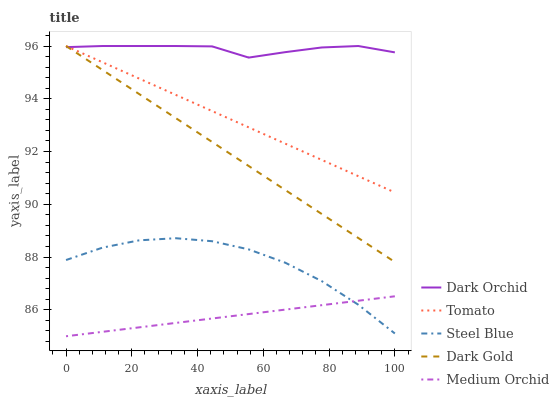Does Medium Orchid have the minimum area under the curve?
Answer yes or no. Yes. Does Dark Orchid have the maximum area under the curve?
Answer yes or no. Yes. Does Steel Blue have the minimum area under the curve?
Answer yes or no. No. Does Steel Blue have the maximum area under the curve?
Answer yes or no. No. Is Medium Orchid the smoothest?
Answer yes or no. Yes. Is Steel Blue the roughest?
Answer yes or no. Yes. Is Steel Blue the smoothest?
Answer yes or no. No. Is Medium Orchid the roughest?
Answer yes or no. No. Does Medium Orchid have the lowest value?
Answer yes or no. Yes. Does Steel Blue have the lowest value?
Answer yes or no. No. Does Dark Gold have the highest value?
Answer yes or no. Yes. Does Steel Blue have the highest value?
Answer yes or no. No. Is Steel Blue less than Dark Gold?
Answer yes or no. Yes. Is Dark Orchid greater than Medium Orchid?
Answer yes or no. Yes. Does Dark Gold intersect Tomato?
Answer yes or no. Yes. Is Dark Gold less than Tomato?
Answer yes or no. No. Is Dark Gold greater than Tomato?
Answer yes or no. No. Does Steel Blue intersect Dark Gold?
Answer yes or no. No. 